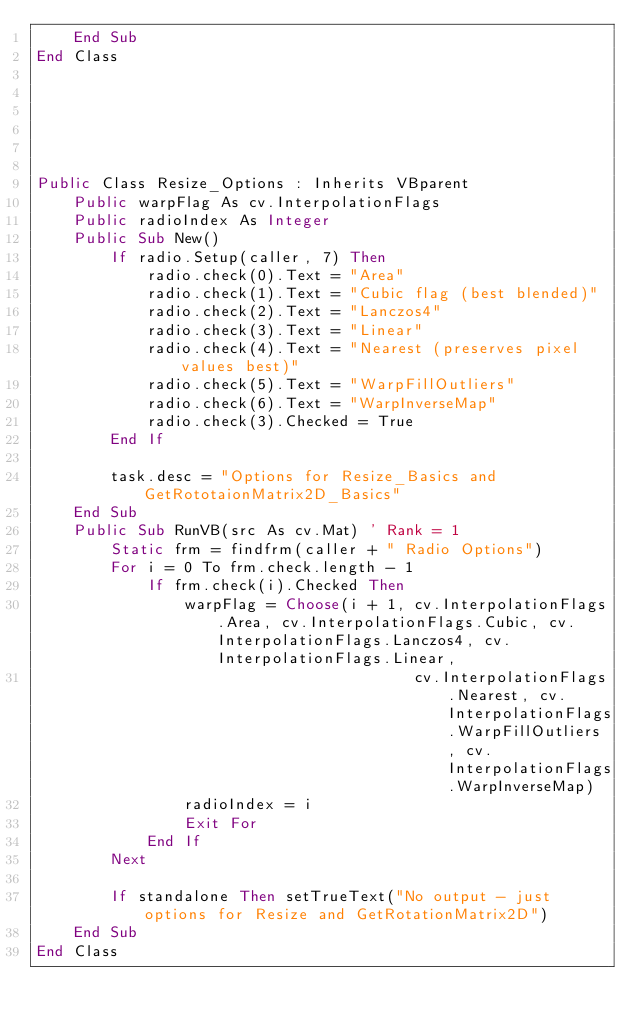Convert code to text. <code><loc_0><loc_0><loc_500><loc_500><_VisualBasic_>    End Sub
End Class






Public Class Resize_Options : Inherits VBparent
    Public warpFlag As cv.InterpolationFlags
    Public radioIndex As Integer
    Public Sub New()
        If radio.Setup(caller, 7) Then
            radio.check(0).Text = "Area"
            radio.check(1).Text = "Cubic flag (best blended)"
            radio.check(2).Text = "Lanczos4"
            radio.check(3).Text = "Linear"
            radio.check(4).Text = "Nearest (preserves pixel values best)"
            radio.check(5).Text = "WarpFillOutliers"
            radio.check(6).Text = "WarpInverseMap"
            radio.check(3).Checked = True
        End If

        task.desc = "Options for Resize_Basics and GetRototaionMatrix2D_Basics"
    End Sub
    Public Sub RunVB(src As cv.Mat) ' Rank = 1
        Static frm = findfrm(caller + " Radio Options")
        For i = 0 To frm.check.length - 1
            If frm.check(i).Checked Then
                warpFlag = Choose(i + 1, cv.InterpolationFlags.Area, cv.InterpolationFlags.Cubic, cv.InterpolationFlags.Lanczos4, cv.InterpolationFlags.Linear,
                                         cv.InterpolationFlags.Nearest, cv.InterpolationFlags.WarpFillOutliers, cv.InterpolationFlags.WarpInverseMap)
                radioIndex = i
                Exit For
            End If
        Next

        If standalone Then setTrueText("No output - just options for Resize and GetRotationMatrix2D")
    End Sub
End Class</code> 